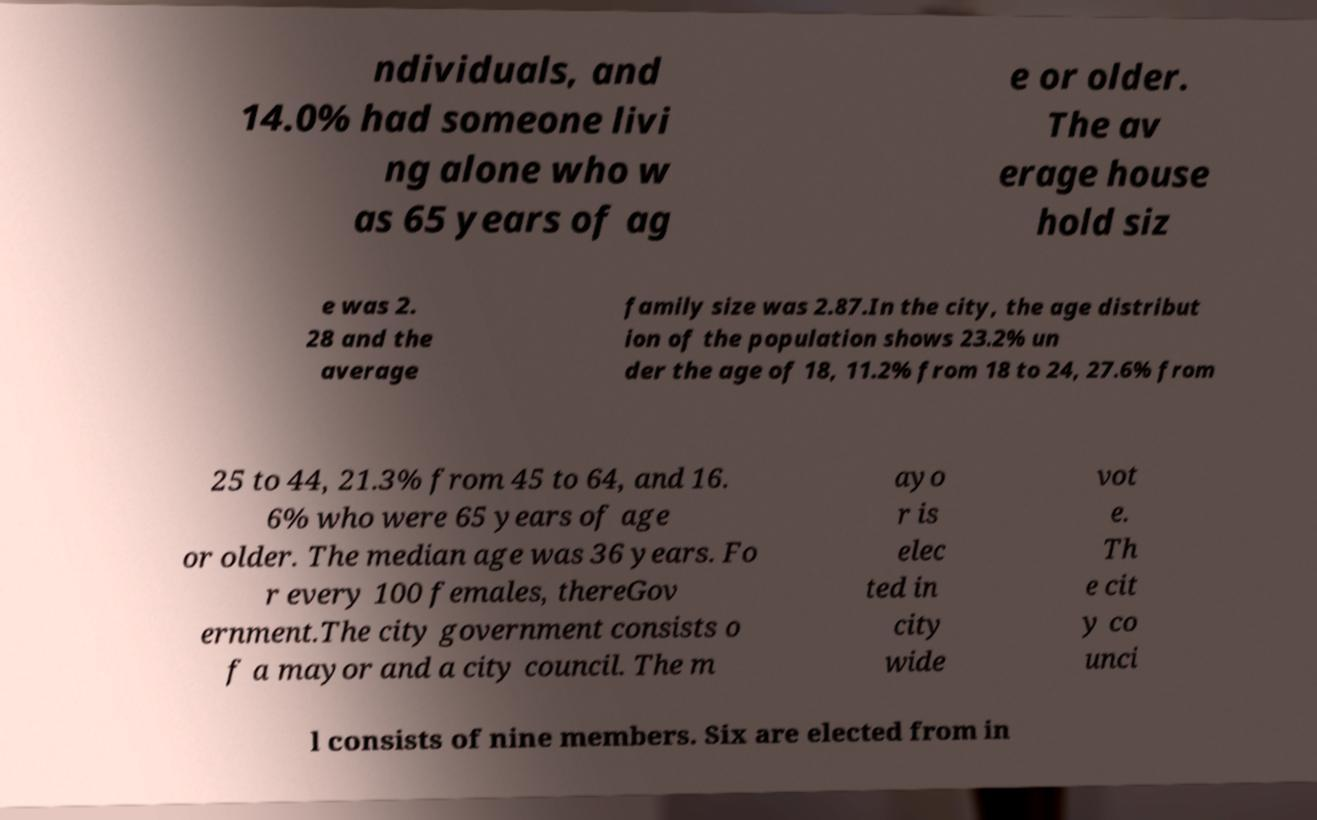Could you assist in decoding the text presented in this image and type it out clearly? ndividuals, and 14.0% had someone livi ng alone who w as 65 years of ag e or older. The av erage house hold siz e was 2. 28 and the average family size was 2.87.In the city, the age distribut ion of the population shows 23.2% un der the age of 18, 11.2% from 18 to 24, 27.6% from 25 to 44, 21.3% from 45 to 64, and 16. 6% who were 65 years of age or older. The median age was 36 years. Fo r every 100 females, thereGov ernment.The city government consists o f a mayor and a city council. The m ayo r is elec ted in city wide vot e. Th e cit y co unci l consists of nine members. Six are elected from in 